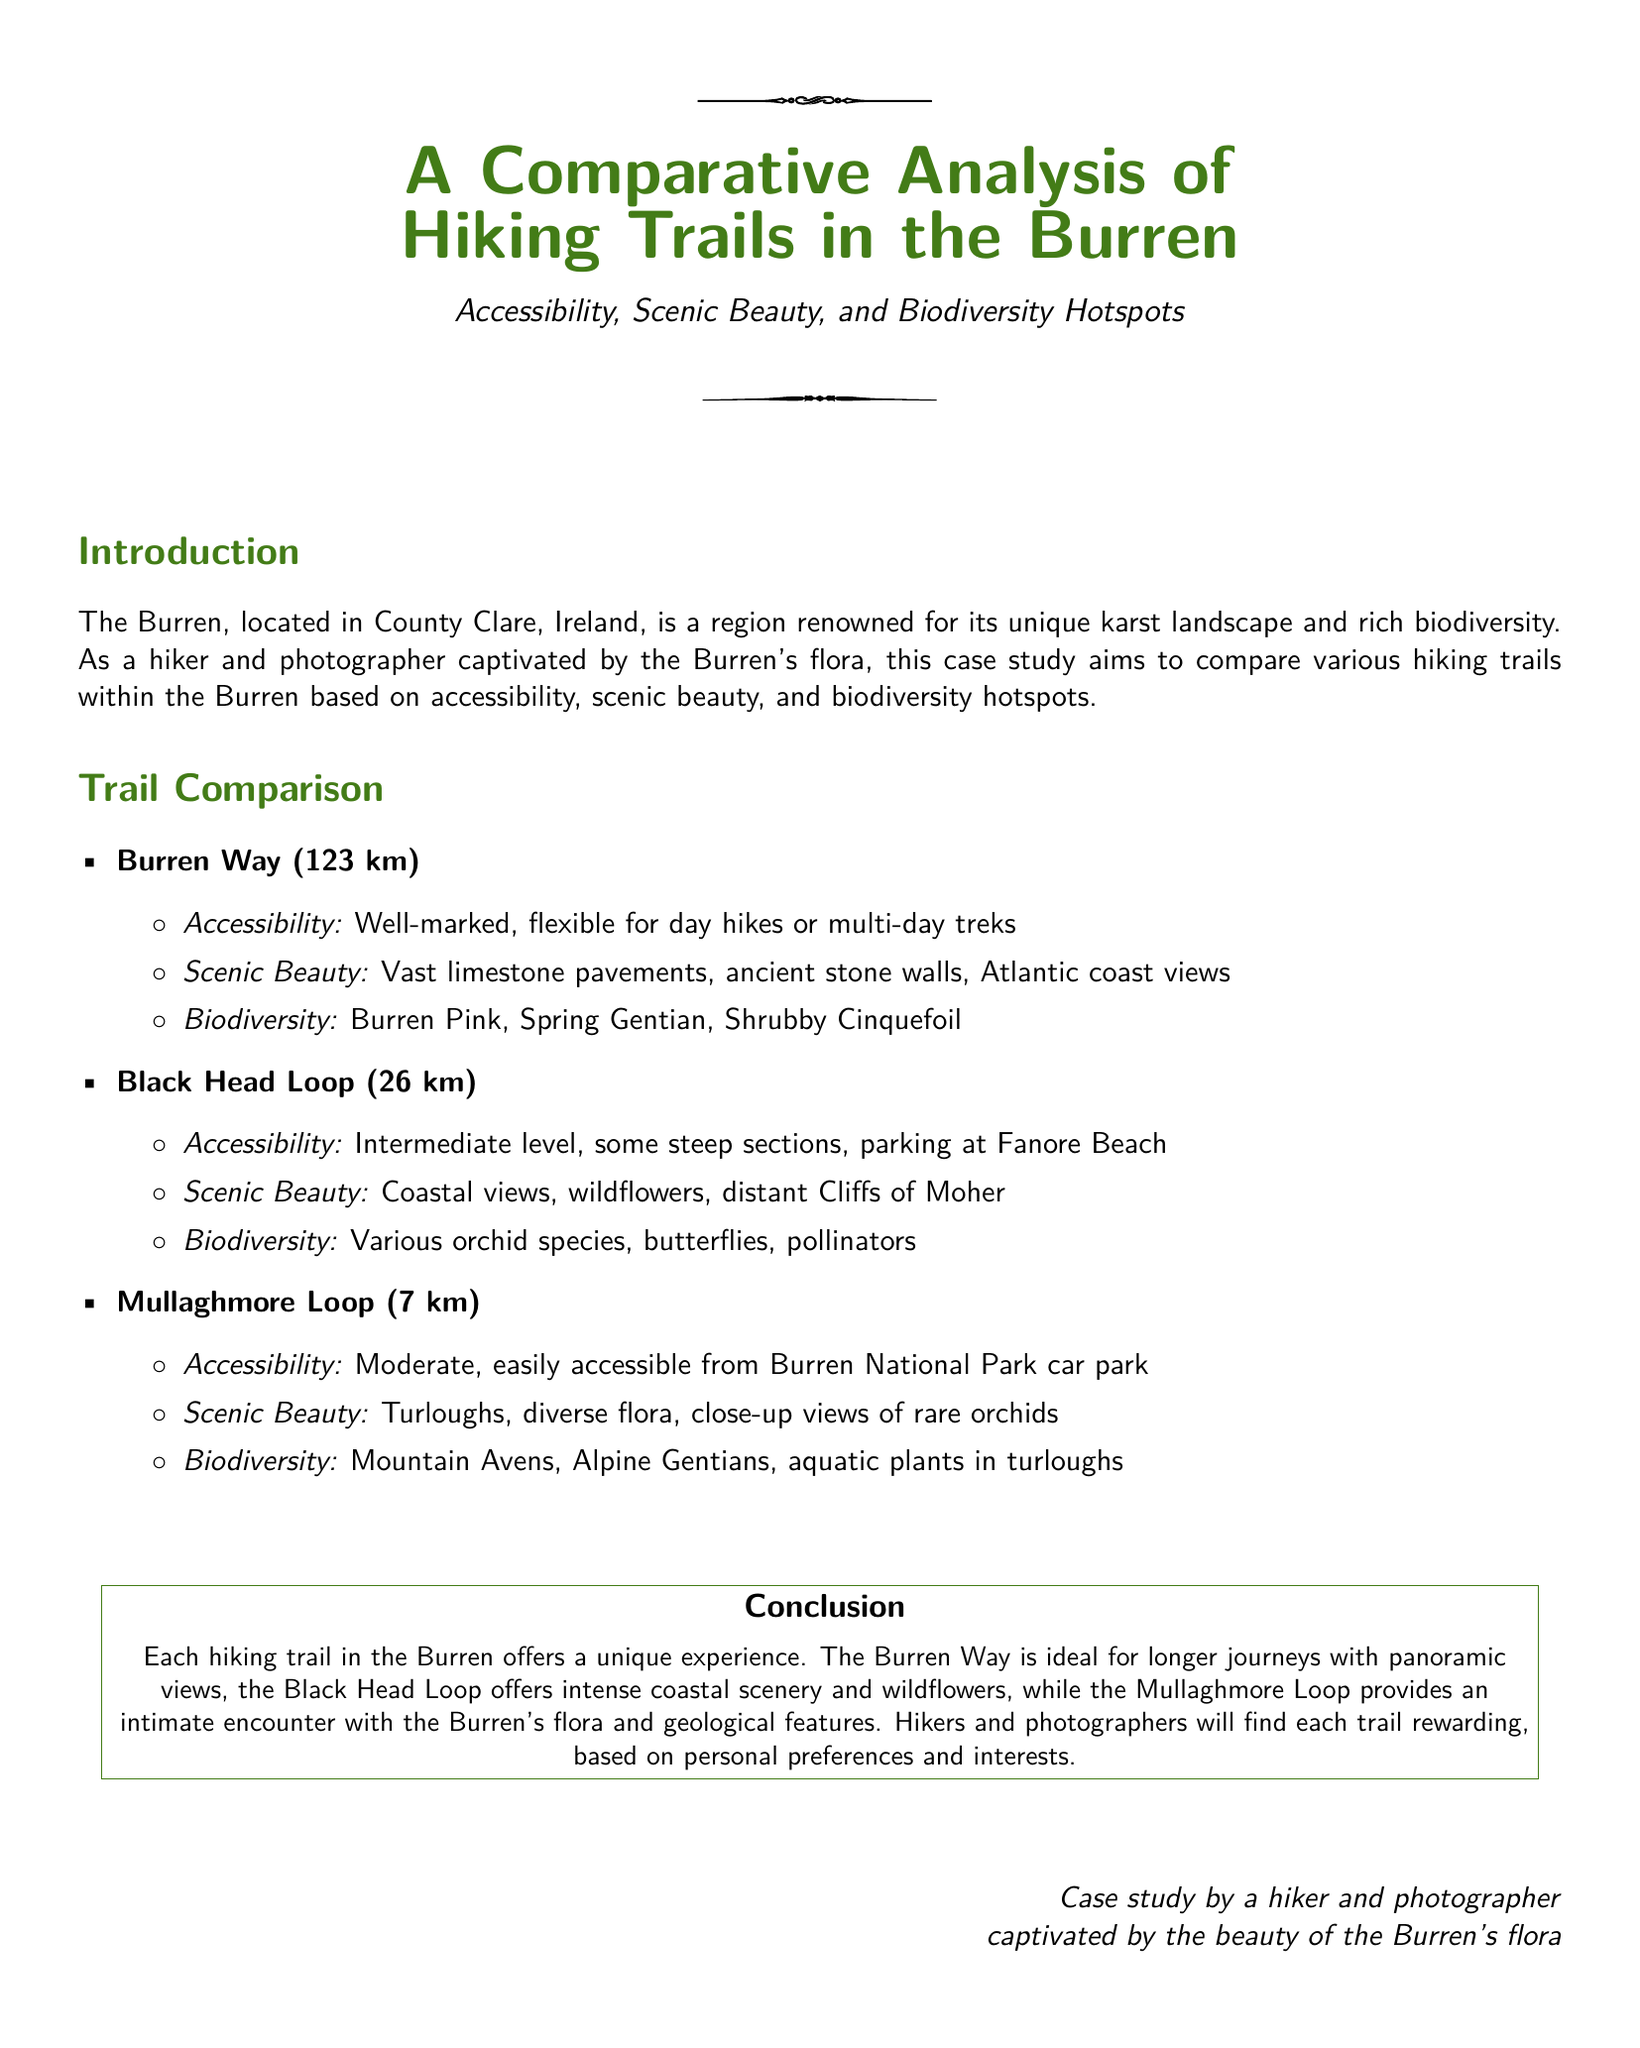what is the length of the Burren Way? The document states that the Burren Way is 123 km long.
Answer: 123 km what type of views does the Black Head Loop offer? The Black Head Loop is noted for its coastal views, wildflowers, and distant Cliffs of Moher.
Answer: Coastal views what is the accessibility level of the Mullaghmore Loop? The document describes the Mullaghmore Loop as having moderate accessibility.
Answer: Moderate which flower is noted in the biodiversity section of the Burren Way? The document mentions "Burren Pink" in relation to the biodiversity of the Burren Way.
Answer: Burren Pink how many kilometers is the Black Head Loop? The Black Head Loop is specified as 26 km in length.
Answer: 26 km what unique geological feature is associated with the Mullaghmore Loop? The Mullaghmore Loop is related to turloughs, which are unique in this region.
Answer: Turloughs which trail is ideal for longer journeys with panoramic views? The document states that the Burren Way is ideal for longer journeys with panoramic views.
Answer: Burren Way what type of species can be found on the Black Head Loop? The document lists various orchid species as part of the biodiversity in the Black Head Loop.
Answer: Various orchid species who is the case study by? The document indicates that the case study is by a hiker and photographer captivated by the beauty of the Burren's flora.
Answer: A hiker and photographer 